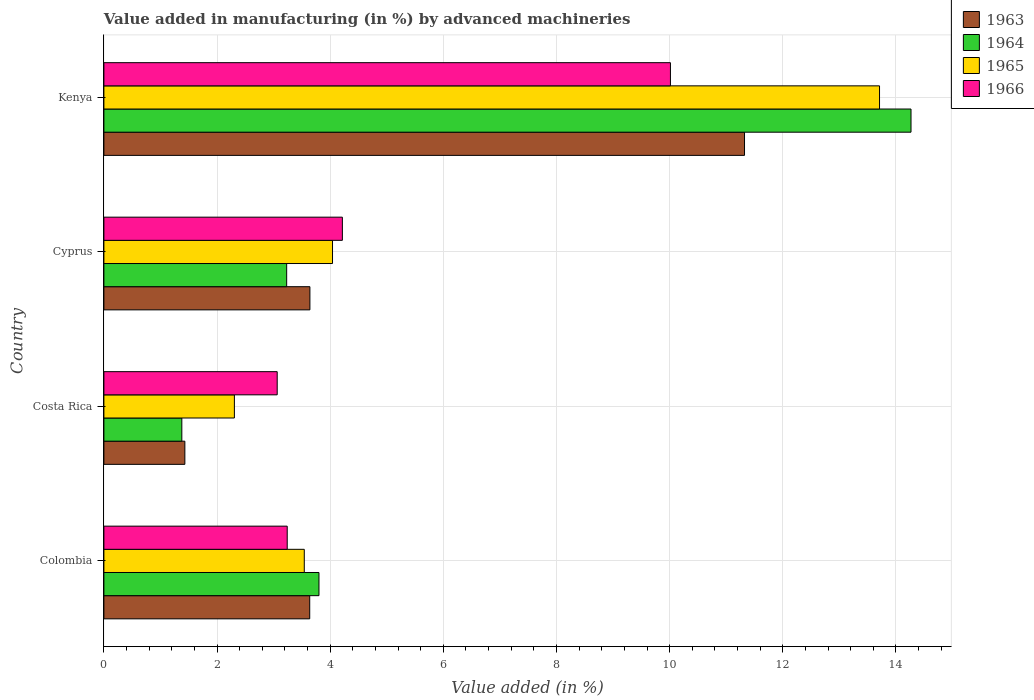How many different coloured bars are there?
Offer a very short reply. 4. Are the number of bars per tick equal to the number of legend labels?
Provide a succinct answer. Yes. How many bars are there on the 4th tick from the top?
Provide a short and direct response. 4. How many bars are there on the 1st tick from the bottom?
Keep it short and to the point. 4. What is the label of the 2nd group of bars from the top?
Your answer should be compact. Cyprus. In how many cases, is the number of bars for a given country not equal to the number of legend labels?
Offer a terse response. 0. What is the percentage of value added in manufacturing by advanced machineries in 1964 in Kenya?
Keep it short and to the point. 14.27. Across all countries, what is the maximum percentage of value added in manufacturing by advanced machineries in 1963?
Ensure brevity in your answer.  11.32. Across all countries, what is the minimum percentage of value added in manufacturing by advanced machineries in 1964?
Ensure brevity in your answer.  1.38. In which country was the percentage of value added in manufacturing by advanced machineries in 1966 maximum?
Provide a short and direct response. Kenya. What is the total percentage of value added in manufacturing by advanced machineries in 1966 in the graph?
Offer a very short reply. 20.53. What is the difference between the percentage of value added in manufacturing by advanced machineries in 1966 in Colombia and that in Costa Rica?
Keep it short and to the point. 0.18. What is the difference between the percentage of value added in manufacturing by advanced machineries in 1964 in Cyprus and the percentage of value added in manufacturing by advanced machineries in 1963 in Costa Rica?
Offer a very short reply. 1.8. What is the average percentage of value added in manufacturing by advanced machineries in 1964 per country?
Give a very brief answer. 5.67. What is the difference between the percentage of value added in manufacturing by advanced machineries in 1964 and percentage of value added in manufacturing by advanced machineries in 1966 in Cyprus?
Give a very brief answer. -0.98. In how many countries, is the percentage of value added in manufacturing by advanced machineries in 1966 greater than 3.6 %?
Give a very brief answer. 2. What is the ratio of the percentage of value added in manufacturing by advanced machineries in 1964 in Colombia to that in Costa Rica?
Ensure brevity in your answer.  2.76. What is the difference between the highest and the second highest percentage of value added in manufacturing by advanced machineries in 1964?
Provide a succinct answer. 10.47. What is the difference between the highest and the lowest percentage of value added in manufacturing by advanced machineries in 1965?
Your answer should be very brief. 11.4. Is the sum of the percentage of value added in manufacturing by advanced machineries in 1965 in Colombia and Kenya greater than the maximum percentage of value added in manufacturing by advanced machineries in 1966 across all countries?
Make the answer very short. Yes. What does the 1st bar from the bottom in Cyprus represents?
Your response must be concise. 1963. Is it the case that in every country, the sum of the percentage of value added in manufacturing by advanced machineries in 1966 and percentage of value added in manufacturing by advanced machineries in 1965 is greater than the percentage of value added in manufacturing by advanced machineries in 1964?
Ensure brevity in your answer.  Yes. How many countries are there in the graph?
Provide a succinct answer. 4. What is the difference between two consecutive major ticks on the X-axis?
Offer a terse response. 2. Are the values on the major ticks of X-axis written in scientific E-notation?
Your answer should be very brief. No. How many legend labels are there?
Provide a short and direct response. 4. How are the legend labels stacked?
Ensure brevity in your answer.  Vertical. What is the title of the graph?
Offer a terse response. Value added in manufacturing (in %) by advanced machineries. Does "1974" appear as one of the legend labels in the graph?
Your response must be concise. No. What is the label or title of the X-axis?
Give a very brief answer. Value added (in %). What is the label or title of the Y-axis?
Offer a terse response. Country. What is the Value added (in %) in 1963 in Colombia?
Give a very brief answer. 3.64. What is the Value added (in %) in 1964 in Colombia?
Your answer should be compact. 3.8. What is the Value added (in %) in 1965 in Colombia?
Provide a short and direct response. 3.54. What is the Value added (in %) in 1966 in Colombia?
Ensure brevity in your answer.  3.24. What is the Value added (in %) of 1963 in Costa Rica?
Your answer should be very brief. 1.43. What is the Value added (in %) of 1964 in Costa Rica?
Give a very brief answer. 1.38. What is the Value added (in %) in 1965 in Costa Rica?
Offer a very short reply. 2.31. What is the Value added (in %) in 1966 in Costa Rica?
Keep it short and to the point. 3.06. What is the Value added (in %) in 1963 in Cyprus?
Ensure brevity in your answer.  3.64. What is the Value added (in %) of 1964 in Cyprus?
Your answer should be compact. 3.23. What is the Value added (in %) of 1965 in Cyprus?
Offer a very short reply. 4.04. What is the Value added (in %) in 1966 in Cyprus?
Your answer should be compact. 4.22. What is the Value added (in %) of 1963 in Kenya?
Provide a succinct answer. 11.32. What is the Value added (in %) in 1964 in Kenya?
Provide a short and direct response. 14.27. What is the Value added (in %) of 1965 in Kenya?
Make the answer very short. 13.71. What is the Value added (in %) in 1966 in Kenya?
Offer a terse response. 10.01. Across all countries, what is the maximum Value added (in %) of 1963?
Provide a short and direct response. 11.32. Across all countries, what is the maximum Value added (in %) of 1964?
Offer a very short reply. 14.27. Across all countries, what is the maximum Value added (in %) in 1965?
Offer a terse response. 13.71. Across all countries, what is the maximum Value added (in %) in 1966?
Provide a succinct answer. 10.01. Across all countries, what is the minimum Value added (in %) in 1963?
Your answer should be very brief. 1.43. Across all countries, what is the minimum Value added (in %) in 1964?
Offer a terse response. 1.38. Across all countries, what is the minimum Value added (in %) in 1965?
Provide a short and direct response. 2.31. Across all countries, what is the minimum Value added (in %) of 1966?
Provide a succinct answer. 3.06. What is the total Value added (in %) in 1963 in the graph?
Offer a terse response. 20.03. What is the total Value added (in %) of 1964 in the graph?
Your response must be concise. 22.68. What is the total Value added (in %) in 1965 in the graph?
Make the answer very short. 23.6. What is the total Value added (in %) of 1966 in the graph?
Keep it short and to the point. 20.53. What is the difference between the Value added (in %) in 1963 in Colombia and that in Costa Rica?
Provide a succinct answer. 2.21. What is the difference between the Value added (in %) in 1964 in Colombia and that in Costa Rica?
Provide a succinct answer. 2.42. What is the difference between the Value added (in %) of 1965 in Colombia and that in Costa Rica?
Your answer should be compact. 1.24. What is the difference between the Value added (in %) in 1966 in Colombia and that in Costa Rica?
Your answer should be compact. 0.18. What is the difference between the Value added (in %) in 1963 in Colombia and that in Cyprus?
Provide a short and direct response. -0. What is the difference between the Value added (in %) of 1964 in Colombia and that in Cyprus?
Your answer should be compact. 0.57. What is the difference between the Value added (in %) of 1965 in Colombia and that in Cyprus?
Your response must be concise. -0.5. What is the difference between the Value added (in %) of 1966 in Colombia and that in Cyprus?
Give a very brief answer. -0.97. What is the difference between the Value added (in %) in 1963 in Colombia and that in Kenya?
Provide a short and direct response. -7.69. What is the difference between the Value added (in %) in 1964 in Colombia and that in Kenya?
Give a very brief answer. -10.47. What is the difference between the Value added (in %) in 1965 in Colombia and that in Kenya?
Give a very brief answer. -10.17. What is the difference between the Value added (in %) of 1966 in Colombia and that in Kenya?
Keep it short and to the point. -6.77. What is the difference between the Value added (in %) of 1963 in Costa Rica and that in Cyprus?
Your response must be concise. -2.21. What is the difference between the Value added (in %) of 1964 in Costa Rica and that in Cyprus?
Offer a terse response. -1.85. What is the difference between the Value added (in %) of 1965 in Costa Rica and that in Cyprus?
Offer a very short reply. -1.73. What is the difference between the Value added (in %) of 1966 in Costa Rica and that in Cyprus?
Give a very brief answer. -1.15. What is the difference between the Value added (in %) in 1963 in Costa Rica and that in Kenya?
Give a very brief answer. -9.89. What is the difference between the Value added (in %) of 1964 in Costa Rica and that in Kenya?
Offer a terse response. -12.89. What is the difference between the Value added (in %) in 1965 in Costa Rica and that in Kenya?
Ensure brevity in your answer.  -11.4. What is the difference between the Value added (in %) of 1966 in Costa Rica and that in Kenya?
Your answer should be compact. -6.95. What is the difference between the Value added (in %) in 1963 in Cyprus and that in Kenya?
Offer a terse response. -7.68. What is the difference between the Value added (in %) in 1964 in Cyprus and that in Kenya?
Keep it short and to the point. -11.04. What is the difference between the Value added (in %) of 1965 in Cyprus and that in Kenya?
Your answer should be compact. -9.67. What is the difference between the Value added (in %) of 1966 in Cyprus and that in Kenya?
Provide a succinct answer. -5.8. What is the difference between the Value added (in %) of 1963 in Colombia and the Value added (in %) of 1964 in Costa Rica?
Provide a short and direct response. 2.26. What is the difference between the Value added (in %) of 1963 in Colombia and the Value added (in %) of 1965 in Costa Rica?
Make the answer very short. 1.33. What is the difference between the Value added (in %) in 1963 in Colombia and the Value added (in %) in 1966 in Costa Rica?
Give a very brief answer. 0.57. What is the difference between the Value added (in %) of 1964 in Colombia and the Value added (in %) of 1965 in Costa Rica?
Your response must be concise. 1.49. What is the difference between the Value added (in %) of 1964 in Colombia and the Value added (in %) of 1966 in Costa Rica?
Make the answer very short. 0.74. What is the difference between the Value added (in %) of 1965 in Colombia and the Value added (in %) of 1966 in Costa Rica?
Your answer should be very brief. 0.48. What is the difference between the Value added (in %) of 1963 in Colombia and the Value added (in %) of 1964 in Cyprus?
Ensure brevity in your answer.  0.41. What is the difference between the Value added (in %) in 1963 in Colombia and the Value added (in %) in 1965 in Cyprus?
Give a very brief answer. -0.4. What is the difference between the Value added (in %) of 1963 in Colombia and the Value added (in %) of 1966 in Cyprus?
Ensure brevity in your answer.  -0.58. What is the difference between the Value added (in %) in 1964 in Colombia and the Value added (in %) in 1965 in Cyprus?
Give a very brief answer. -0.24. What is the difference between the Value added (in %) of 1964 in Colombia and the Value added (in %) of 1966 in Cyprus?
Your answer should be very brief. -0.41. What is the difference between the Value added (in %) of 1965 in Colombia and the Value added (in %) of 1966 in Cyprus?
Offer a terse response. -0.67. What is the difference between the Value added (in %) of 1963 in Colombia and the Value added (in %) of 1964 in Kenya?
Keep it short and to the point. -10.63. What is the difference between the Value added (in %) of 1963 in Colombia and the Value added (in %) of 1965 in Kenya?
Keep it short and to the point. -10.07. What is the difference between the Value added (in %) in 1963 in Colombia and the Value added (in %) in 1966 in Kenya?
Offer a terse response. -6.38. What is the difference between the Value added (in %) of 1964 in Colombia and the Value added (in %) of 1965 in Kenya?
Offer a very short reply. -9.91. What is the difference between the Value added (in %) in 1964 in Colombia and the Value added (in %) in 1966 in Kenya?
Ensure brevity in your answer.  -6.21. What is the difference between the Value added (in %) of 1965 in Colombia and the Value added (in %) of 1966 in Kenya?
Your answer should be very brief. -6.47. What is the difference between the Value added (in %) of 1963 in Costa Rica and the Value added (in %) of 1964 in Cyprus?
Keep it short and to the point. -1.8. What is the difference between the Value added (in %) in 1963 in Costa Rica and the Value added (in %) in 1965 in Cyprus?
Your response must be concise. -2.61. What is the difference between the Value added (in %) in 1963 in Costa Rica and the Value added (in %) in 1966 in Cyprus?
Give a very brief answer. -2.78. What is the difference between the Value added (in %) of 1964 in Costa Rica and the Value added (in %) of 1965 in Cyprus?
Your answer should be compact. -2.66. What is the difference between the Value added (in %) of 1964 in Costa Rica and the Value added (in %) of 1966 in Cyprus?
Provide a succinct answer. -2.84. What is the difference between the Value added (in %) of 1965 in Costa Rica and the Value added (in %) of 1966 in Cyprus?
Your answer should be very brief. -1.91. What is the difference between the Value added (in %) in 1963 in Costa Rica and the Value added (in %) in 1964 in Kenya?
Offer a terse response. -12.84. What is the difference between the Value added (in %) in 1963 in Costa Rica and the Value added (in %) in 1965 in Kenya?
Your response must be concise. -12.28. What is the difference between the Value added (in %) of 1963 in Costa Rica and the Value added (in %) of 1966 in Kenya?
Provide a short and direct response. -8.58. What is the difference between the Value added (in %) in 1964 in Costa Rica and the Value added (in %) in 1965 in Kenya?
Make the answer very short. -12.33. What is the difference between the Value added (in %) in 1964 in Costa Rica and the Value added (in %) in 1966 in Kenya?
Ensure brevity in your answer.  -8.64. What is the difference between the Value added (in %) in 1965 in Costa Rica and the Value added (in %) in 1966 in Kenya?
Provide a succinct answer. -7.71. What is the difference between the Value added (in %) in 1963 in Cyprus and the Value added (in %) in 1964 in Kenya?
Your answer should be compact. -10.63. What is the difference between the Value added (in %) of 1963 in Cyprus and the Value added (in %) of 1965 in Kenya?
Offer a very short reply. -10.07. What is the difference between the Value added (in %) of 1963 in Cyprus and the Value added (in %) of 1966 in Kenya?
Provide a short and direct response. -6.37. What is the difference between the Value added (in %) in 1964 in Cyprus and the Value added (in %) in 1965 in Kenya?
Provide a succinct answer. -10.48. What is the difference between the Value added (in %) in 1964 in Cyprus and the Value added (in %) in 1966 in Kenya?
Your answer should be very brief. -6.78. What is the difference between the Value added (in %) in 1965 in Cyprus and the Value added (in %) in 1966 in Kenya?
Your answer should be very brief. -5.97. What is the average Value added (in %) of 1963 per country?
Offer a very short reply. 5.01. What is the average Value added (in %) of 1964 per country?
Your answer should be very brief. 5.67. What is the average Value added (in %) in 1966 per country?
Offer a terse response. 5.13. What is the difference between the Value added (in %) in 1963 and Value added (in %) in 1964 in Colombia?
Your answer should be very brief. -0.16. What is the difference between the Value added (in %) in 1963 and Value added (in %) in 1965 in Colombia?
Provide a succinct answer. 0.1. What is the difference between the Value added (in %) of 1963 and Value added (in %) of 1966 in Colombia?
Give a very brief answer. 0.4. What is the difference between the Value added (in %) in 1964 and Value added (in %) in 1965 in Colombia?
Your response must be concise. 0.26. What is the difference between the Value added (in %) of 1964 and Value added (in %) of 1966 in Colombia?
Offer a terse response. 0.56. What is the difference between the Value added (in %) of 1965 and Value added (in %) of 1966 in Colombia?
Ensure brevity in your answer.  0.3. What is the difference between the Value added (in %) in 1963 and Value added (in %) in 1964 in Costa Rica?
Your response must be concise. 0.05. What is the difference between the Value added (in %) in 1963 and Value added (in %) in 1965 in Costa Rica?
Provide a succinct answer. -0.88. What is the difference between the Value added (in %) of 1963 and Value added (in %) of 1966 in Costa Rica?
Give a very brief answer. -1.63. What is the difference between the Value added (in %) of 1964 and Value added (in %) of 1965 in Costa Rica?
Your response must be concise. -0.93. What is the difference between the Value added (in %) in 1964 and Value added (in %) in 1966 in Costa Rica?
Keep it short and to the point. -1.69. What is the difference between the Value added (in %) of 1965 and Value added (in %) of 1966 in Costa Rica?
Your answer should be compact. -0.76. What is the difference between the Value added (in %) of 1963 and Value added (in %) of 1964 in Cyprus?
Your response must be concise. 0.41. What is the difference between the Value added (in %) of 1963 and Value added (in %) of 1965 in Cyprus?
Make the answer very short. -0.4. What is the difference between the Value added (in %) of 1963 and Value added (in %) of 1966 in Cyprus?
Your answer should be very brief. -0.57. What is the difference between the Value added (in %) in 1964 and Value added (in %) in 1965 in Cyprus?
Give a very brief answer. -0.81. What is the difference between the Value added (in %) of 1964 and Value added (in %) of 1966 in Cyprus?
Offer a very short reply. -0.98. What is the difference between the Value added (in %) in 1965 and Value added (in %) in 1966 in Cyprus?
Provide a short and direct response. -0.17. What is the difference between the Value added (in %) of 1963 and Value added (in %) of 1964 in Kenya?
Keep it short and to the point. -2.94. What is the difference between the Value added (in %) in 1963 and Value added (in %) in 1965 in Kenya?
Your answer should be compact. -2.39. What is the difference between the Value added (in %) in 1963 and Value added (in %) in 1966 in Kenya?
Provide a short and direct response. 1.31. What is the difference between the Value added (in %) in 1964 and Value added (in %) in 1965 in Kenya?
Provide a succinct answer. 0.56. What is the difference between the Value added (in %) of 1964 and Value added (in %) of 1966 in Kenya?
Offer a terse response. 4.25. What is the difference between the Value added (in %) in 1965 and Value added (in %) in 1966 in Kenya?
Give a very brief answer. 3.7. What is the ratio of the Value added (in %) of 1963 in Colombia to that in Costa Rica?
Your response must be concise. 2.54. What is the ratio of the Value added (in %) in 1964 in Colombia to that in Costa Rica?
Provide a succinct answer. 2.76. What is the ratio of the Value added (in %) in 1965 in Colombia to that in Costa Rica?
Keep it short and to the point. 1.54. What is the ratio of the Value added (in %) of 1966 in Colombia to that in Costa Rica?
Offer a very short reply. 1.06. What is the ratio of the Value added (in %) of 1964 in Colombia to that in Cyprus?
Provide a succinct answer. 1.18. What is the ratio of the Value added (in %) in 1965 in Colombia to that in Cyprus?
Offer a terse response. 0.88. What is the ratio of the Value added (in %) in 1966 in Colombia to that in Cyprus?
Give a very brief answer. 0.77. What is the ratio of the Value added (in %) in 1963 in Colombia to that in Kenya?
Provide a short and direct response. 0.32. What is the ratio of the Value added (in %) in 1964 in Colombia to that in Kenya?
Make the answer very short. 0.27. What is the ratio of the Value added (in %) in 1965 in Colombia to that in Kenya?
Give a very brief answer. 0.26. What is the ratio of the Value added (in %) of 1966 in Colombia to that in Kenya?
Give a very brief answer. 0.32. What is the ratio of the Value added (in %) of 1963 in Costa Rica to that in Cyprus?
Your answer should be compact. 0.39. What is the ratio of the Value added (in %) of 1964 in Costa Rica to that in Cyprus?
Offer a very short reply. 0.43. What is the ratio of the Value added (in %) of 1965 in Costa Rica to that in Cyprus?
Give a very brief answer. 0.57. What is the ratio of the Value added (in %) in 1966 in Costa Rica to that in Cyprus?
Offer a very short reply. 0.73. What is the ratio of the Value added (in %) of 1963 in Costa Rica to that in Kenya?
Make the answer very short. 0.13. What is the ratio of the Value added (in %) of 1964 in Costa Rica to that in Kenya?
Keep it short and to the point. 0.1. What is the ratio of the Value added (in %) of 1965 in Costa Rica to that in Kenya?
Your answer should be very brief. 0.17. What is the ratio of the Value added (in %) in 1966 in Costa Rica to that in Kenya?
Give a very brief answer. 0.31. What is the ratio of the Value added (in %) in 1963 in Cyprus to that in Kenya?
Your answer should be compact. 0.32. What is the ratio of the Value added (in %) in 1964 in Cyprus to that in Kenya?
Keep it short and to the point. 0.23. What is the ratio of the Value added (in %) of 1965 in Cyprus to that in Kenya?
Your response must be concise. 0.29. What is the ratio of the Value added (in %) of 1966 in Cyprus to that in Kenya?
Ensure brevity in your answer.  0.42. What is the difference between the highest and the second highest Value added (in %) in 1963?
Your answer should be very brief. 7.68. What is the difference between the highest and the second highest Value added (in %) in 1964?
Offer a very short reply. 10.47. What is the difference between the highest and the second highest Value added (in %) in 1965?
Make the answer very short. 9.67. What is the difference between the highest and the second highest Value added (in %) of 1966?
Your response must be concise. 5.8. What is the difference between the highest and the lowest Value added (in %) of 1963?
Offer a very short reply. 9.89. What is the difference between the highest and the lowest Value added (in %) of 1964?
Ensure brevity in your answer.  12.89. What is the difference between the highest and the lowest Value added (in %) in 1965?
Your answer should be very brief. 11.4. What is the difference between the highest and the lowest Value added (in %) in 1966?
Give a very brief answer. 6.95. 